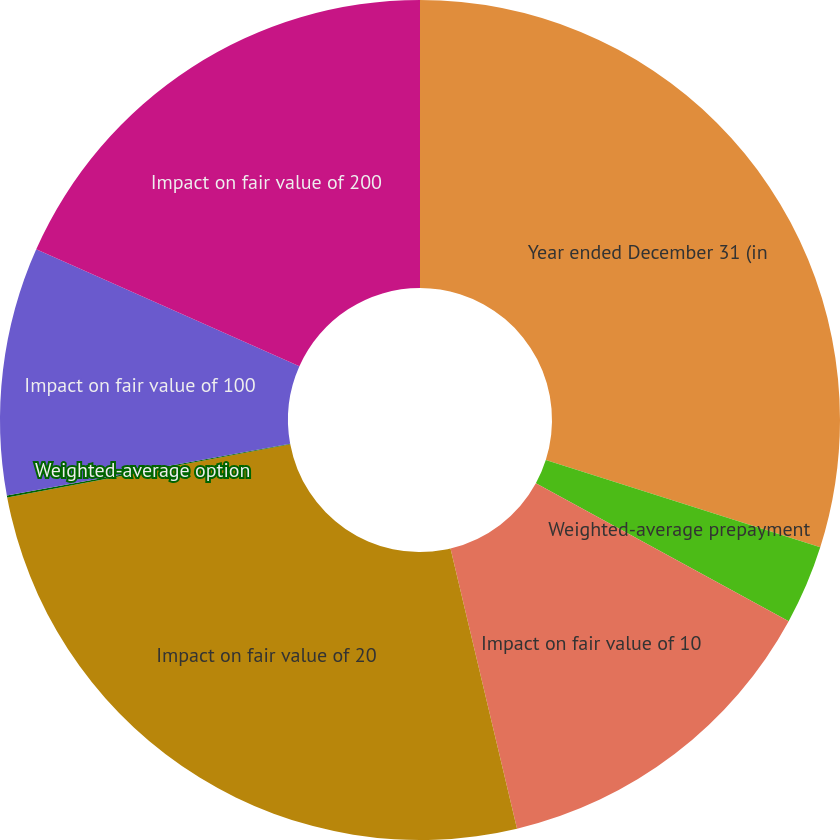<chart> <loc_0><loc_0><loc_500><loc_500><pie_chart><fcel>Year ended December 31 (in<fcel>Weighted-average prepayment<fcel>Impact on fair value of 10<fcel>Impact on fair value of 20<fcel>Weighted-average option<fcel>Impact on fair value of 100<fcel>Impact on fair value of 200<nl><fcel>29.9%<fcel>3.05%<fcel>13.34%<fcel>25.76%<fcel>0.07%<fcel>9.54%<fcel>18.34%<nl></chart> 